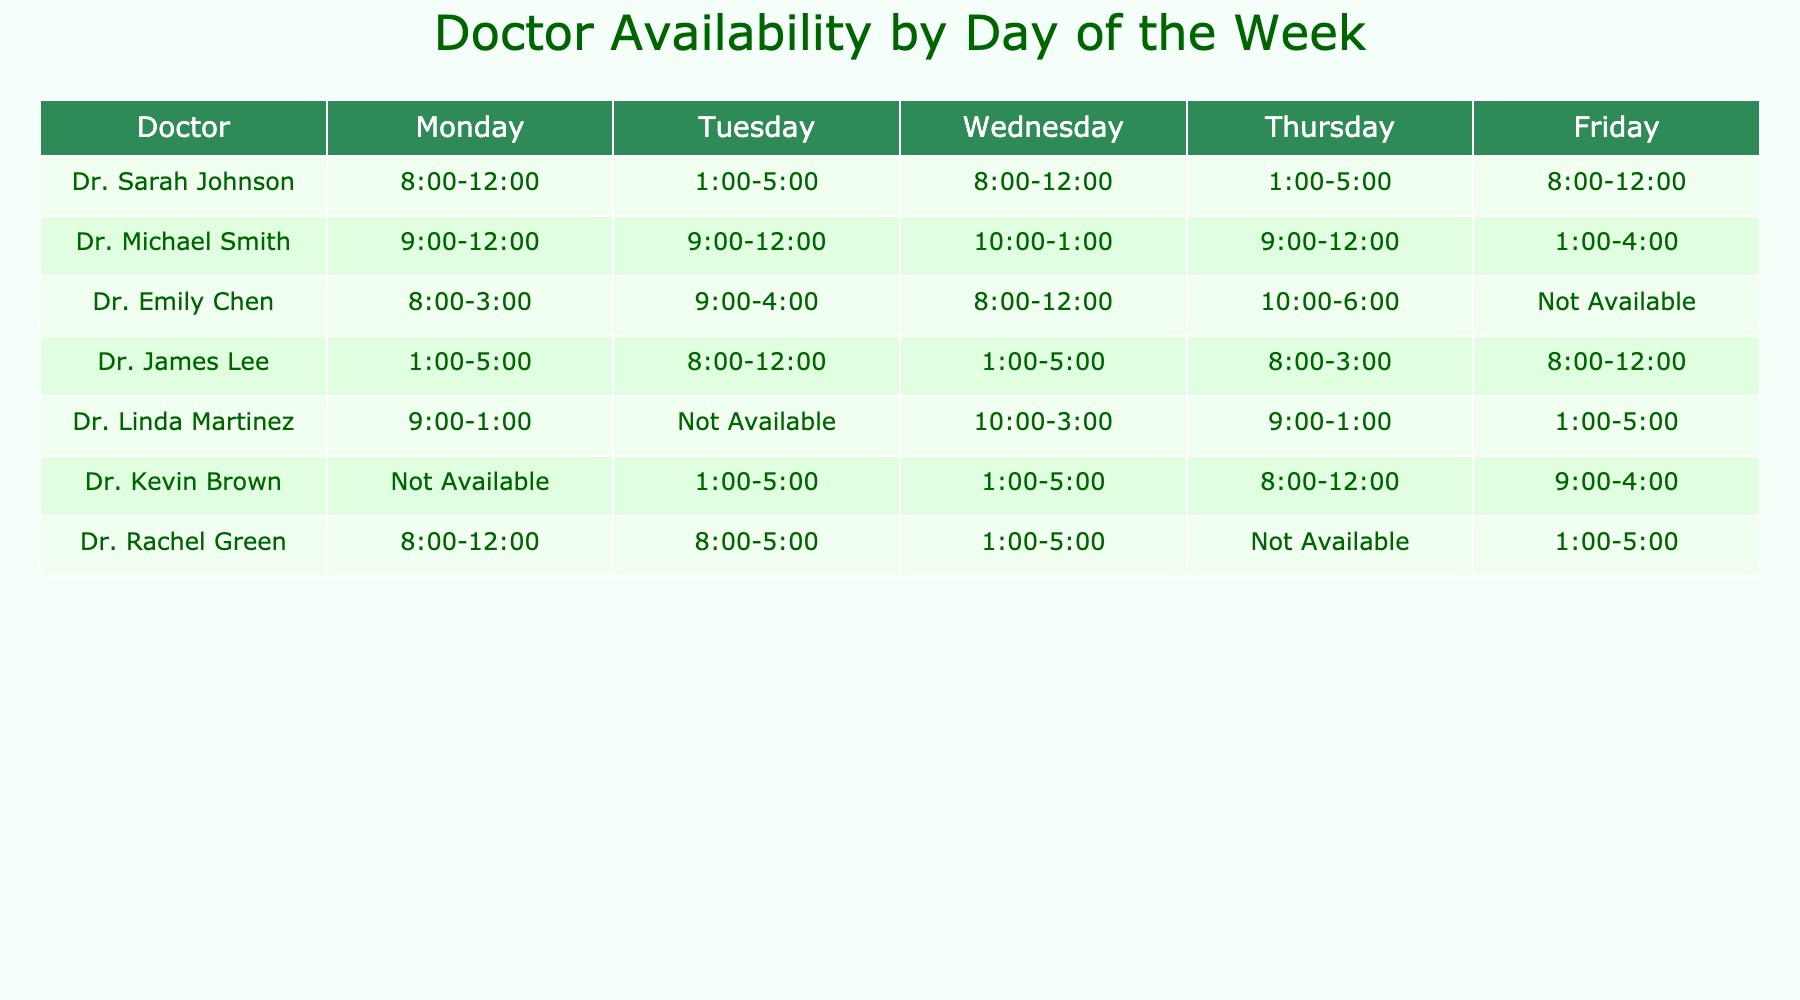What are Dr. Sarah Johnson's working hours on Thursday? Looking at the row for Dr. Sarah Johnson, her working hours are listed as 1:00-5:00 on Thursday.
Answer: 1:00-5:00 Which doctor is available on Monday from 8:00 to 12:00? From the table, Dr. Sarah Johnson and Dr. Rachel Green are both available on Monday during these hours (8:00-12:00).
Answer: Dr. Sarah Johnson and Dr. Rachel Green How many doctors are available on Tuesday? On Tuesday, the following doctors are available: Dr. Michael Smith, Dr. James Lee, Dr. Kevin Brown, and Dr. Rachel Green, making a total of four doctors.
Answer: 4 Is Dr. Emily Chen available on Friday? The table indicates that Dr. Emily Chen is marked as "Not Available" on Friday.
Answer: No Which doctor has the longest continuous availability in hours on Wednesday? To determine the longest availability on Wednesday, I compare the time slots: Dr. Michael Smith (3 hours), Dr. James Lee (4 hours), Dr. Emily Chen (4 hours), and Dr. Rachel Green (4 hours). Here, Dr. James Lee, Dr. Emily Chen, and Dr. Rachel Green all have the longest availability of 4 hours.
Answer: Dr. James Lee, Dr. Emily Chen, and Dr. Rachel Green On which day does Dr. Linda Martinez have no availability? In the table, it is clear that Dr. Linda Martinez is marked as "Not Available" on Tuesday.
Answer: Tuesday How many days is Dr. Kevin Brown available? By checking the availability for Dr. Kevin Brown, he is available on Tuesday, Wednesday, Thursday, and Friday, totaling four days.
Answer: 4 Which doctor is consistently available for morning shifts? Looking at the availability, Dr. Sarah Johnson and Dr. Rachel Green have consistent morning shifts available on Monday, making them both suitable candidates.
Answer: Dr. Sarah Johnson and Dr. Rachel Green What is the average availability of Dr. Michael Smith based on the hours displayed? Dr. Michael Smith has the following availability: 3 hours on Monday and Tuesday, 3 hours on Wednesday, and 4 hours on Thursday, and 3 hours on Friday. The total hours are 3 + 3 + 3 + 4 + 3 = 16 hours. Given 5 days, the average is 16/5 = 3.2 hours.
Answer: 3.2 hours 